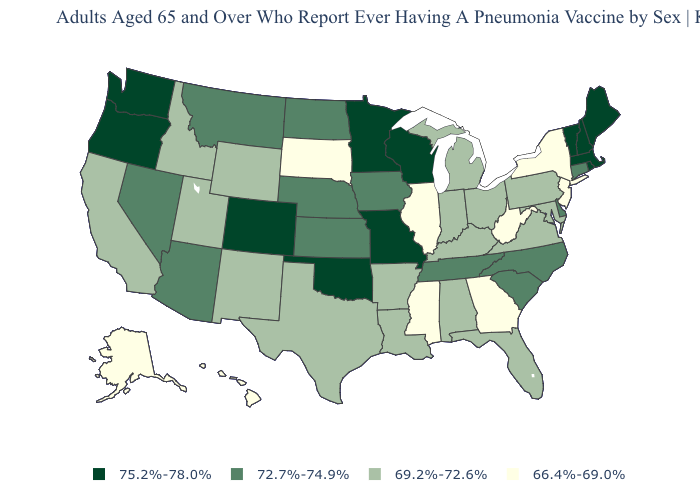Name the states that have a value in the range 75.2%-78.0%?
Short answer required. Colorado, Maine, Massachusetts, Minnesota, Missouri, New Hampshire, Oklahoma, Oregon, Rhode Island, Vermont, Washington, Wisconsin. What is the value of Kentucky?
Give a very brief answer. 69.2%-72.6%. Does Maine have a higher value than South Dakota?
Give a very brief answer. Yes. Name the states that have a value in the range 75.2%-78.0%?
Answer briefly. Colorado, Maine, Massachusetts, Minnesota, Missouri, New Hampshire, Oklahoma, Oregon, Rhode Island, Vermont, Washington, Wisconsin. Does New York have the lowest value in the Northeast?
Write a very short answer. Yes. How many symbols are there in the legend?
Be succinct. 4. Does Massachusetts have a lower value than Illinois?
Short answer required. No. Name the states that have a value in the range 69.2%-72.6%?
Short answer required. Alabama, Arkansas, California, Florida, Idaho, Indiana, Kentucky, Louisiana, Maryland, Michigan, New Mexico, Ohio, Pennsylvania, Texas, Utah, Virginia, Wyoming. Among the states that border North Dakota , which have the lowest value?
Keep it brief. South Dakota. Is the legend a continuous bar?
Be succinct. No. What is the lowest value in the USA?
Concise answer only. 66.4%-69.0%. Name the states that have a value in the range 72.7%-74.9%?
Answer briefly. Arizona, Connecticut, Delaware, Iowa, Kansas, Montana, Nebraska, Nevada, North Carolina, North Dakota, South Carolina, Tennessee. What is the value of New Jersey?
Write a very short answer. 66.4%-69.0%. Which states hav the highest value in the West?
Concise answer only. Colorado, Oregon, Washington. Name the states that have a value in the range 69.2%-72.6%?
Short answer required. Alabama, Arkansas, California, Florida, Idaho, Indiana, Kentucky, Louisiana, Maryland, Michigan, New Mexico, Ohio, Pennsylvania, Texas, Utah, Virginia, Wyoming. 